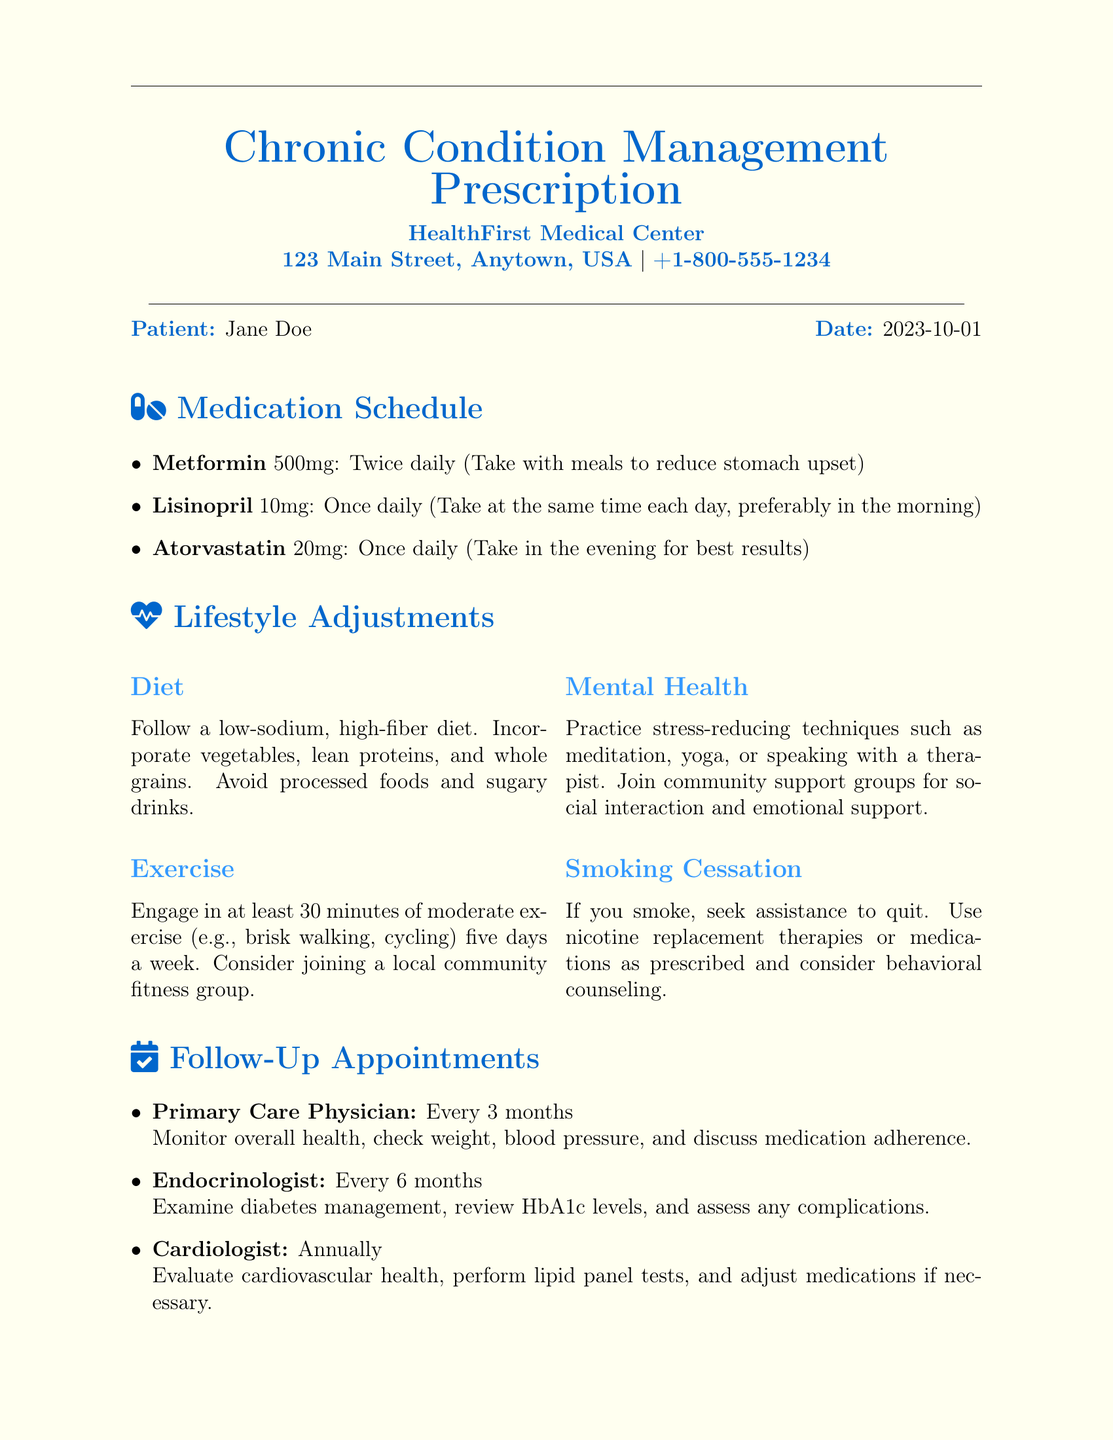What is the patient's name? The patient's name is provided in the document as Jane Doe.
Answer: Jane Doe How often should the patient visit the primary care physician? The document specifies that the patient should visit the primary care physician every 3 months.
Answer: Every 3 months What medication is prescribed to be taken with meals? The medication that should be taken with meals, as stated in the document, is Metformin.
Answer: Metformin What dietary recommendation is given in the lifestyle adjustments? The document advises following a low-sodium, high-fiber diet.
Answer: Low-sodium, high-fiber diet How long should the patient engage in moderate exercise each week? The document indicates that the patient should engage in at least 30 minutes of exercise five days a week.
Answer: 30 minutes, five days a week When is the next follow-up appointment with the endocrinologist? The document states the endocrinologist appointment is scheduled every 6 months, with the date not specified in the document.
Answer: Every 6 months What is one mental health practice recommended? The document recommends practicing stress-reducing techniques such as meditation or yoga.
Answer: Meditation or yoga Who prescribed the medication? The document attributes the prescription to Dr. John Smith.
Answer: Dr. John Smith 